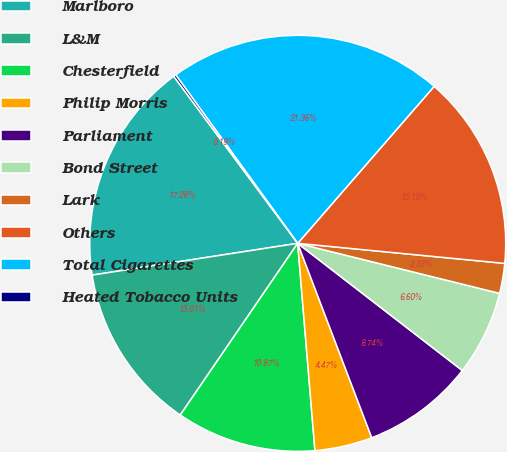Convert chart. <chart><loc_0><loc_0><loc_500><loc_500><pie_chart><fcel>Marlboro<fcel>L&M<fcel>Chesterfield<fcel>Philip Morris<fcel>Parliament<fcel>Bond Street<fcel>Lark<fcel>Others<fcel>Total Cigarettes<fcel>Heated Tobacco Units<nl><fcel>17.28%<fcel>13.01%<fcel>10.87%<fcel>4.47%<fcel>8.74%<fcel>6.6%<fcel>2.33%<fcel>15.15%<fcel>21.36%<fcel>0.19%<nl></chart> 